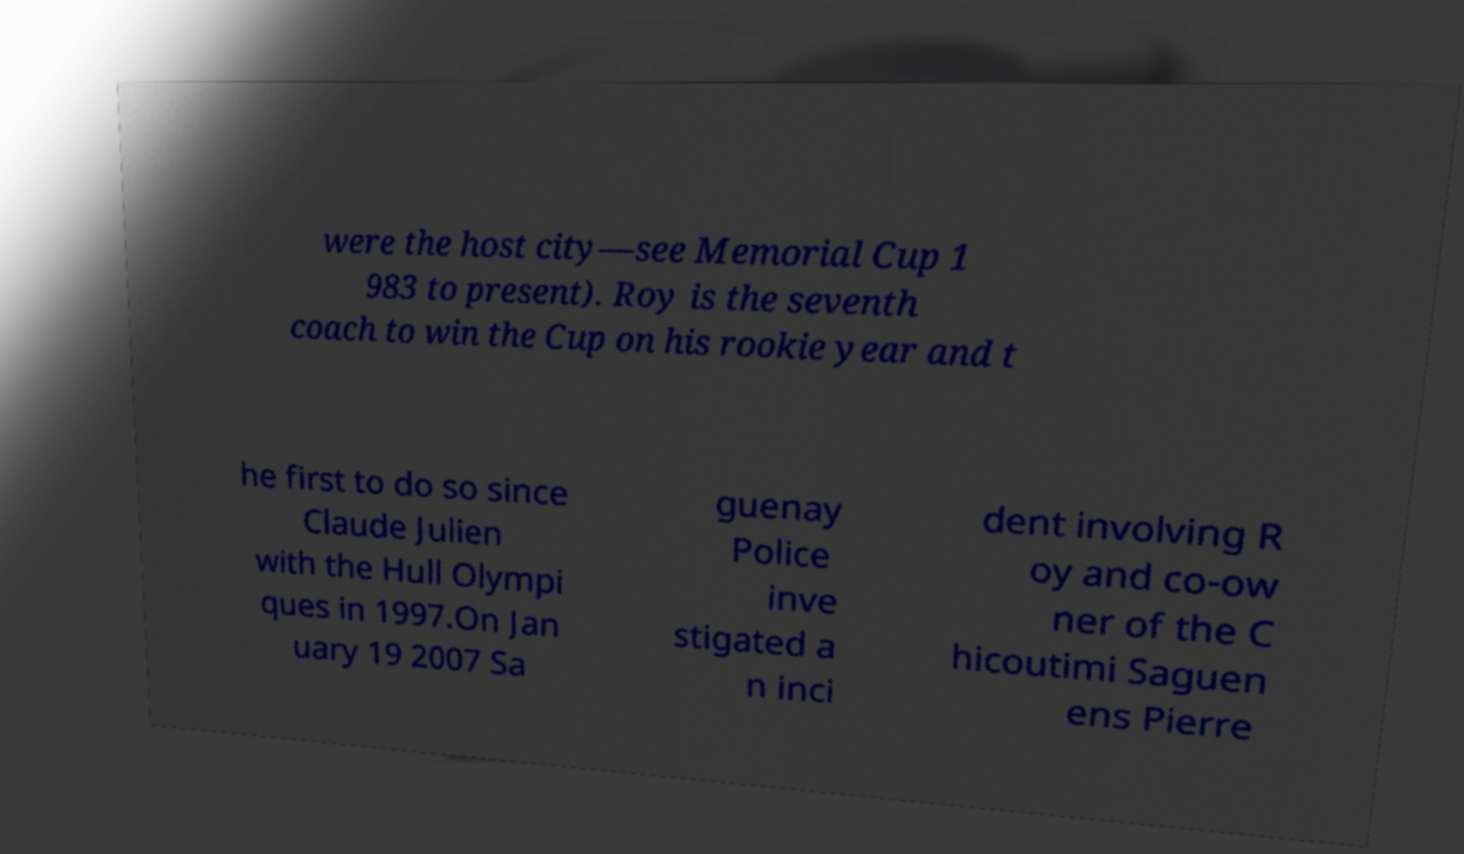Can you read and provide the text displayed in the image?This photo seems to have some interesting text. Can you extract and type it out for me? were the host city—see Memorial Cup 1 983 to present). Roy is the seventh coach to win the Cup on his rookie year and t he first to do so since Claude Julien with the Hull Olympi ques in 1997.On Jan uary 19 2007 Sa guenay Police inve stigated a n inci dent involving R oy and co-ow ner of the C hicoutimi Saguen ens Pierre 